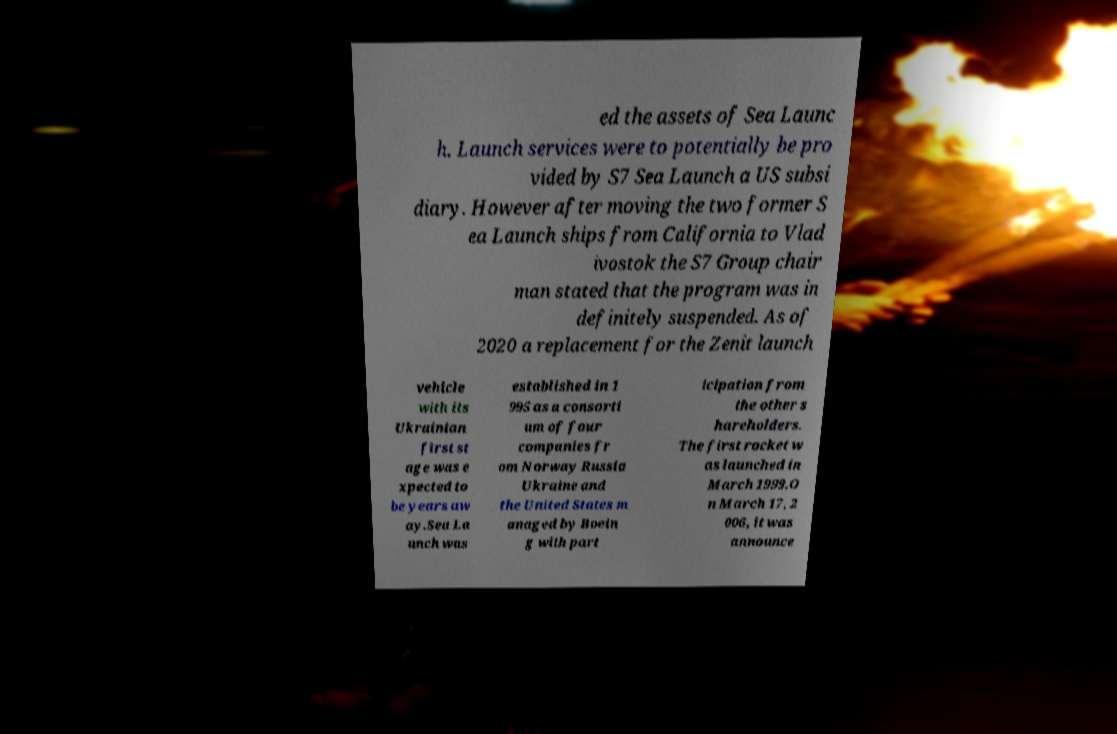Please identify and transcribe the text found in this image. ed the assets of Sea Launc h. Launch services were to potentially be pro vided by S7 Sea Launch a US subsi diary. However after moving the two former S ea Launch ships from California to Vlad ivostok the S7 Group chair man stated that the program was in definitely suspended. As of 2020 a replacement for the Zenit launch vehicle with its Ukrainian first st age was e xpected to be years aw ay.Sea La unch was established in 1 995 as a consorti um of four companies fr om Norway Russia Ukraine and the United States m anaged by Boein g with part icipation from the other s hareholders. The first rocket w as launched in March 1999.O n March 17, 2 006, it was announce 